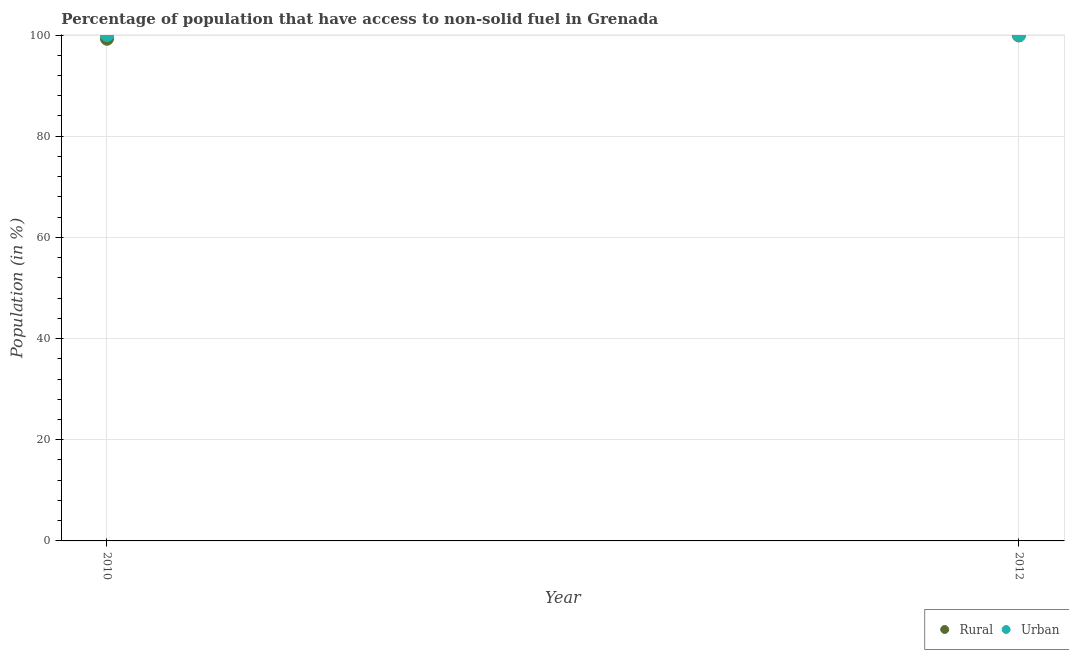How many different coloured dotlines are there?
Your answer should be very brief. 2. Is the number of dotlines equal to the number of legend labels?
Provide a succinct answer. Yes. What is the urban population in 2010?
Offer a very short reply. 100. Across all years, what is the maximum urban population?
Offer a terse response. 100. Across all years, what is the minimum urban population?
Your answer should be very brief. 100. In which year was the urban population maximum?
Make the answer very short. 2010. What is the total urban population in the graph?
Ensure brevity in your answer.  200. What is the difference between the rural population in 2010 and that in 2012?
Ensure brevity in your answer.  -0.65. What is the difference between the rural population in 2010 and the urban population in 2012?
Provide a short and direct response. -0.73. What is the average rural population per year?
Provide a succinct answer. 99.6. In the year 2010, what is the difference between the rural population and urban population?
Your answer should be compact. -0.73. What is the ratio of the rural population in 2010 to that in 2012?
Give a very brief answer. 0.99. Is the urban population strictly less than the rural population over the years?
Your answer should be very brief. No. How many dotlines are there?
Provide a succinct answer. 2. Where does the legend appear in the graph?
Keep it short and to the point. Bottom right. How are the legend labels stacked?
Provide a succinct answer. Horizontal. What is the title of the graph?
Offer a terse response. Percentage of population that have access to non-solid fuel in Grenada. Does "Lower secondary education" appear as one of the legend labels in the graph?
Your answer should be very brief. No. What is the Population (in %) in Rural in 2010?
Ensure brevity in your answer.  99.27. What is the Population (in %) in Rural in 2012?
Keep it short and to the point. 99.93. Across all years, what is the maximum Population (in %) in Rural?
Give a very brief answer. 99.93. Across all years, what is the maximum Population (in %) of Urban?
Ensure brevity in your answer.  100. Across all years, what is the minimum Population (in %) in Rural?
Offer a very short reply. 99.27. What is the total Population (in %) of Rural in the graph?
Give a very brief answer. 199.2. What is the difference between the Population (in %) of Rural in 2010 and that in 2012?
Your response must be concise. -0.65. What is the difference between the Population (in %) in Rural in 2010 and the Population (in %) in Urban in 2012?
Your response must be concise. -0.73. What is the average Population (in %) of Rural per year?
Make the answer very short. 99.6. What is the average Population (in %) of Urban per year?
Your answer should be compact. 100. In the year 2010, what is the difference between the Population (in %) of Rural and Population (in %) of Urban?
Offer a terse response. -0.73. In the year 2012, what is the difference between the Population (in %) in Rural and Population (in %) in Urban?
Give a very brief answer. -0.07. What is the ratio of the Population (in %) in Rural in 2010 to that in 2012?
Your response must be concise. 0.99. What is the ratio of the Population (in %) of Urban in 2010 to that in 2012?
Ensure brevity in your answer.  1. What is the difference between the highest and the second highest Population (in %) of Rural?
Ensure brevity in your answer.  0.65. What is the difference between the highest and the second highest Population (in %) in Urban?
Make the answer very short. 0. What is the difference between the highest and the lowest Population (in %) of Rural?
Provide a succinct answer. 0.65. What is the difference between the highest and the lowest Population (in %) of Urban?
Offer a very short reply. 0. 